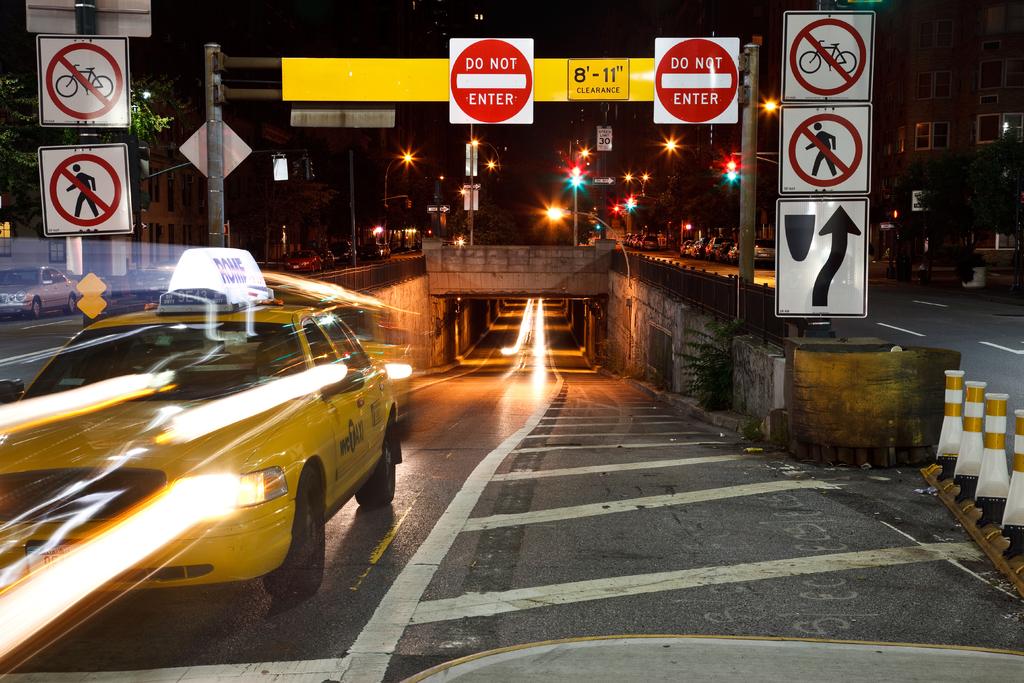What does one of the signs on the street say?
Your answer should be compact. Do not enter. What does the stop sign say?
Provide a succinct answer. Do not enter. 